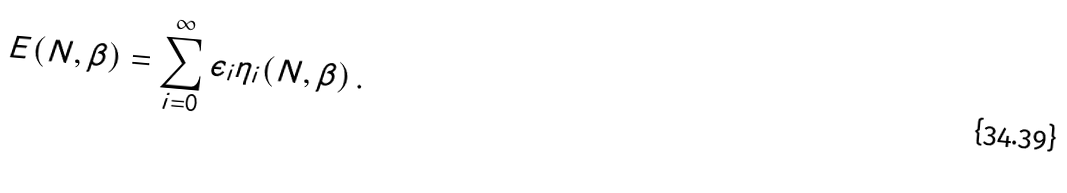Convert formula to latex. <formula><loc_0><loc_0><loc_500><loc_500>E ( N , \beta ) = \sum _ { i = 0 } ^ { \infty } \epsilon _ { i } \eta _ { i } ( N , \beta ) \, .</formula> 